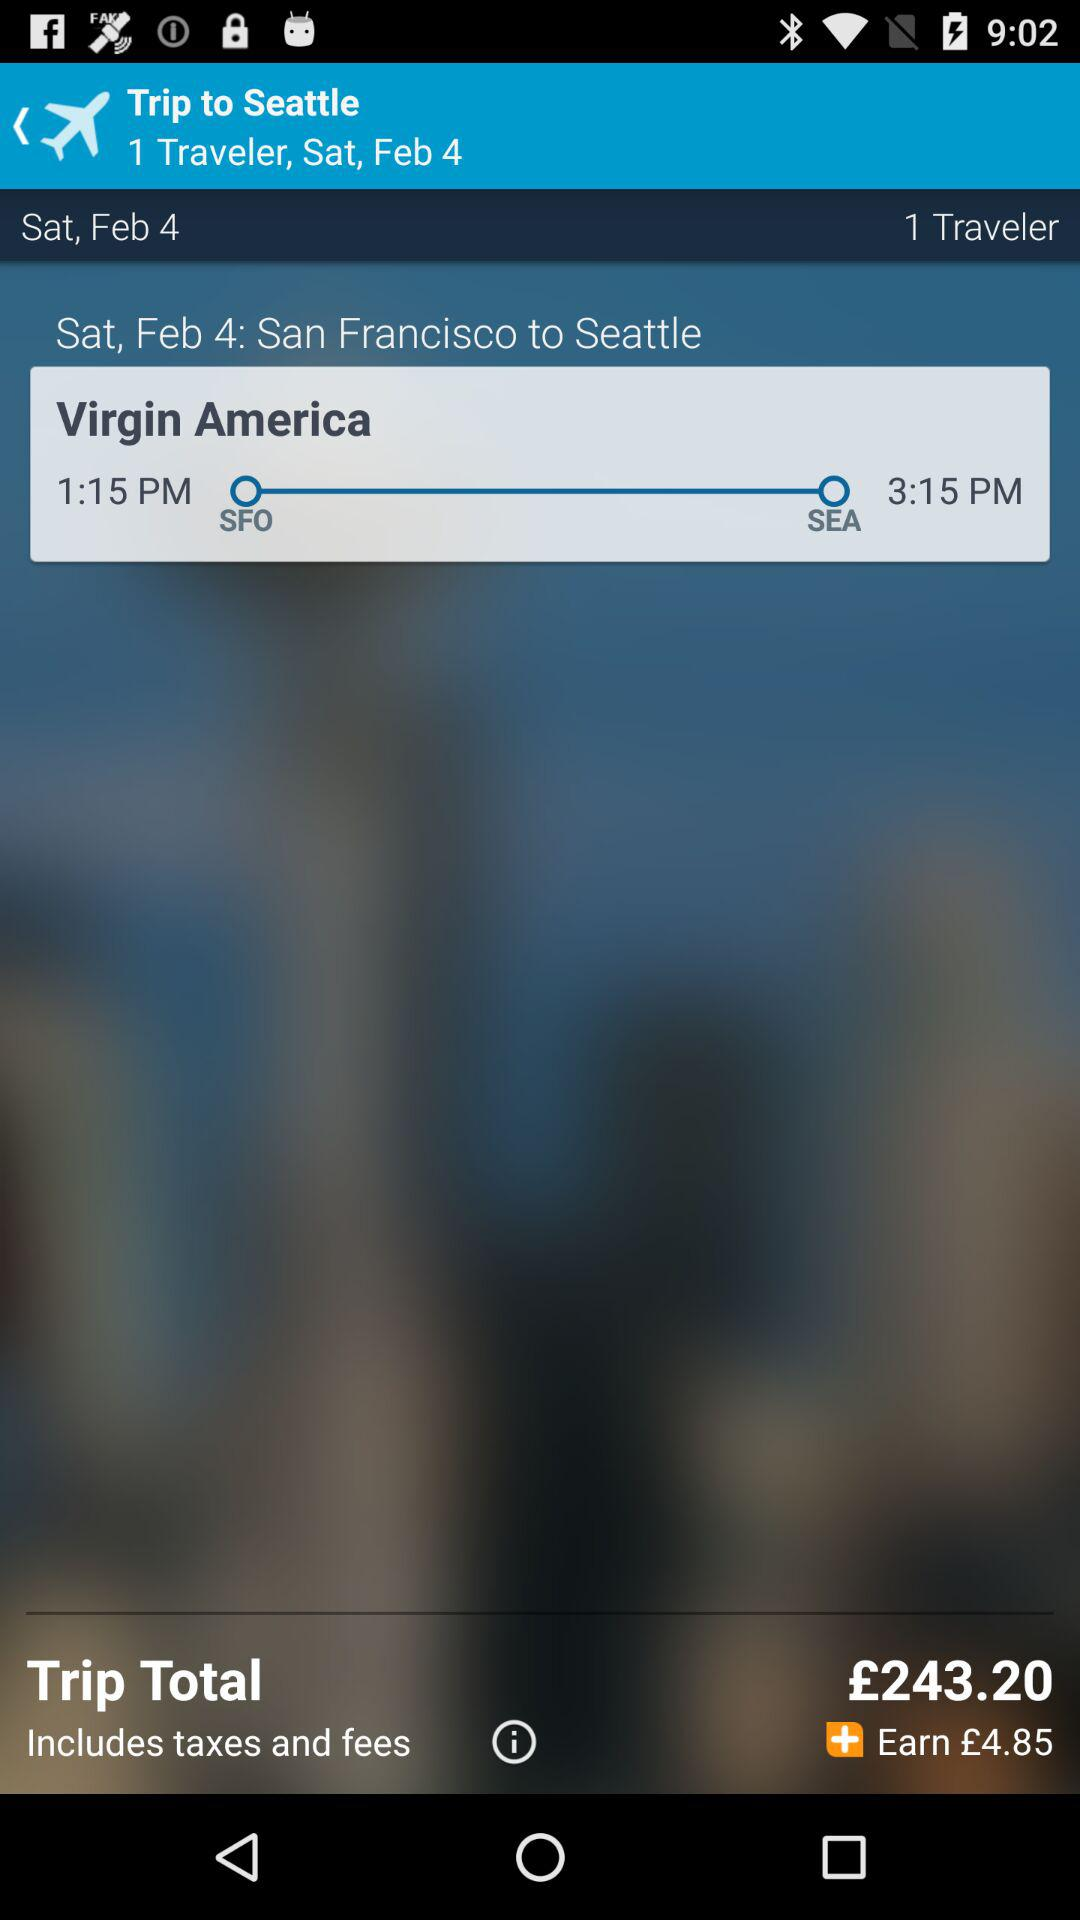What is the total amount of taxes and fees?
When the provided information is insufficient, respond with <no answer>. <no answer> 